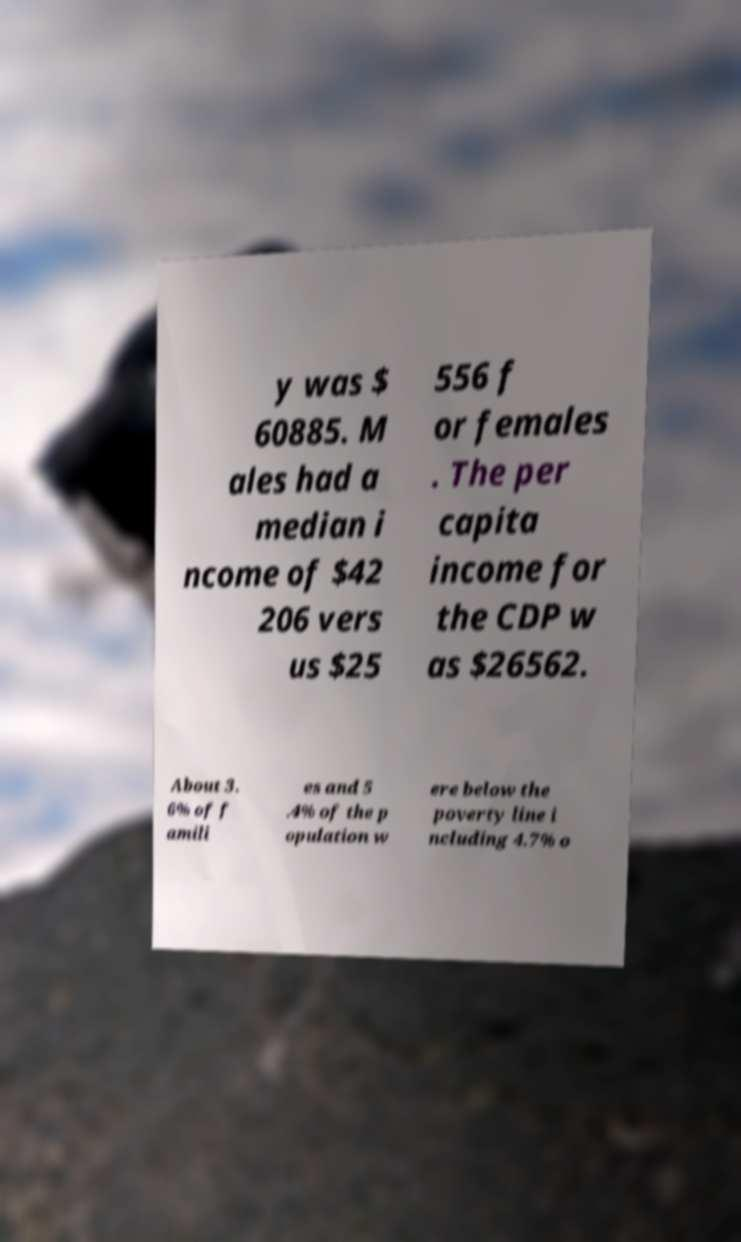What messages or text are displayed in this image? I need them in a readable, typed format. y was $ 60885. M ales had a median i ncome of $42 206 vers us $25 556 f or females . The per capita income for the CDP w as $26562. About 3. 6% of f amili es and 5 .4% of the p opulation w ere below the poverty line i ncluding 4.7% o 